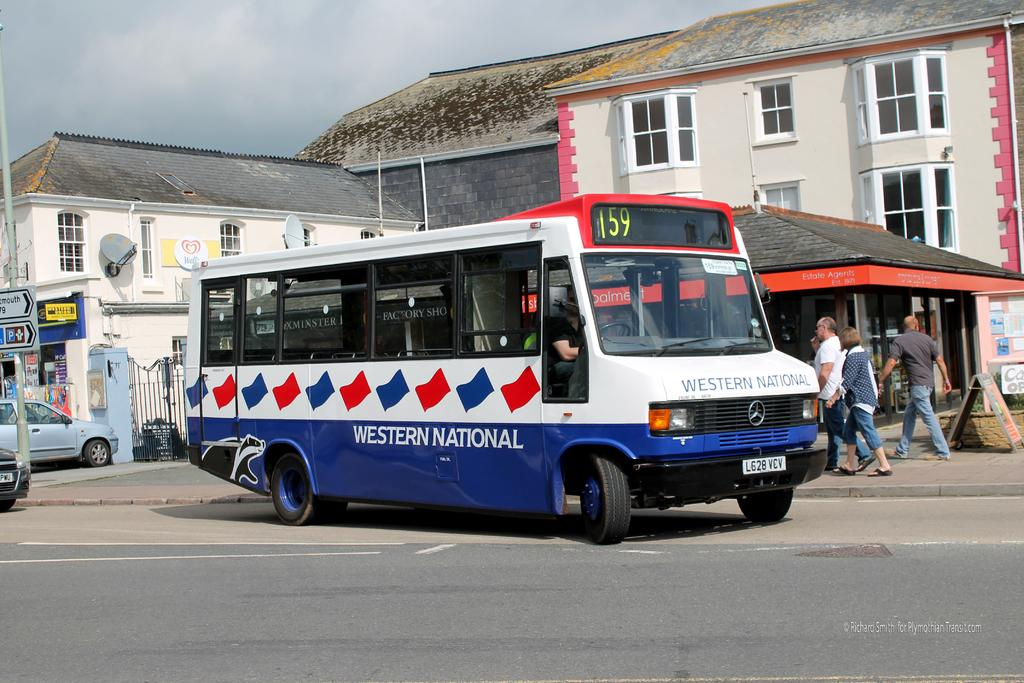<image>
Provide a brief description of the given image. Western National bus number 159 is driving along the street. 